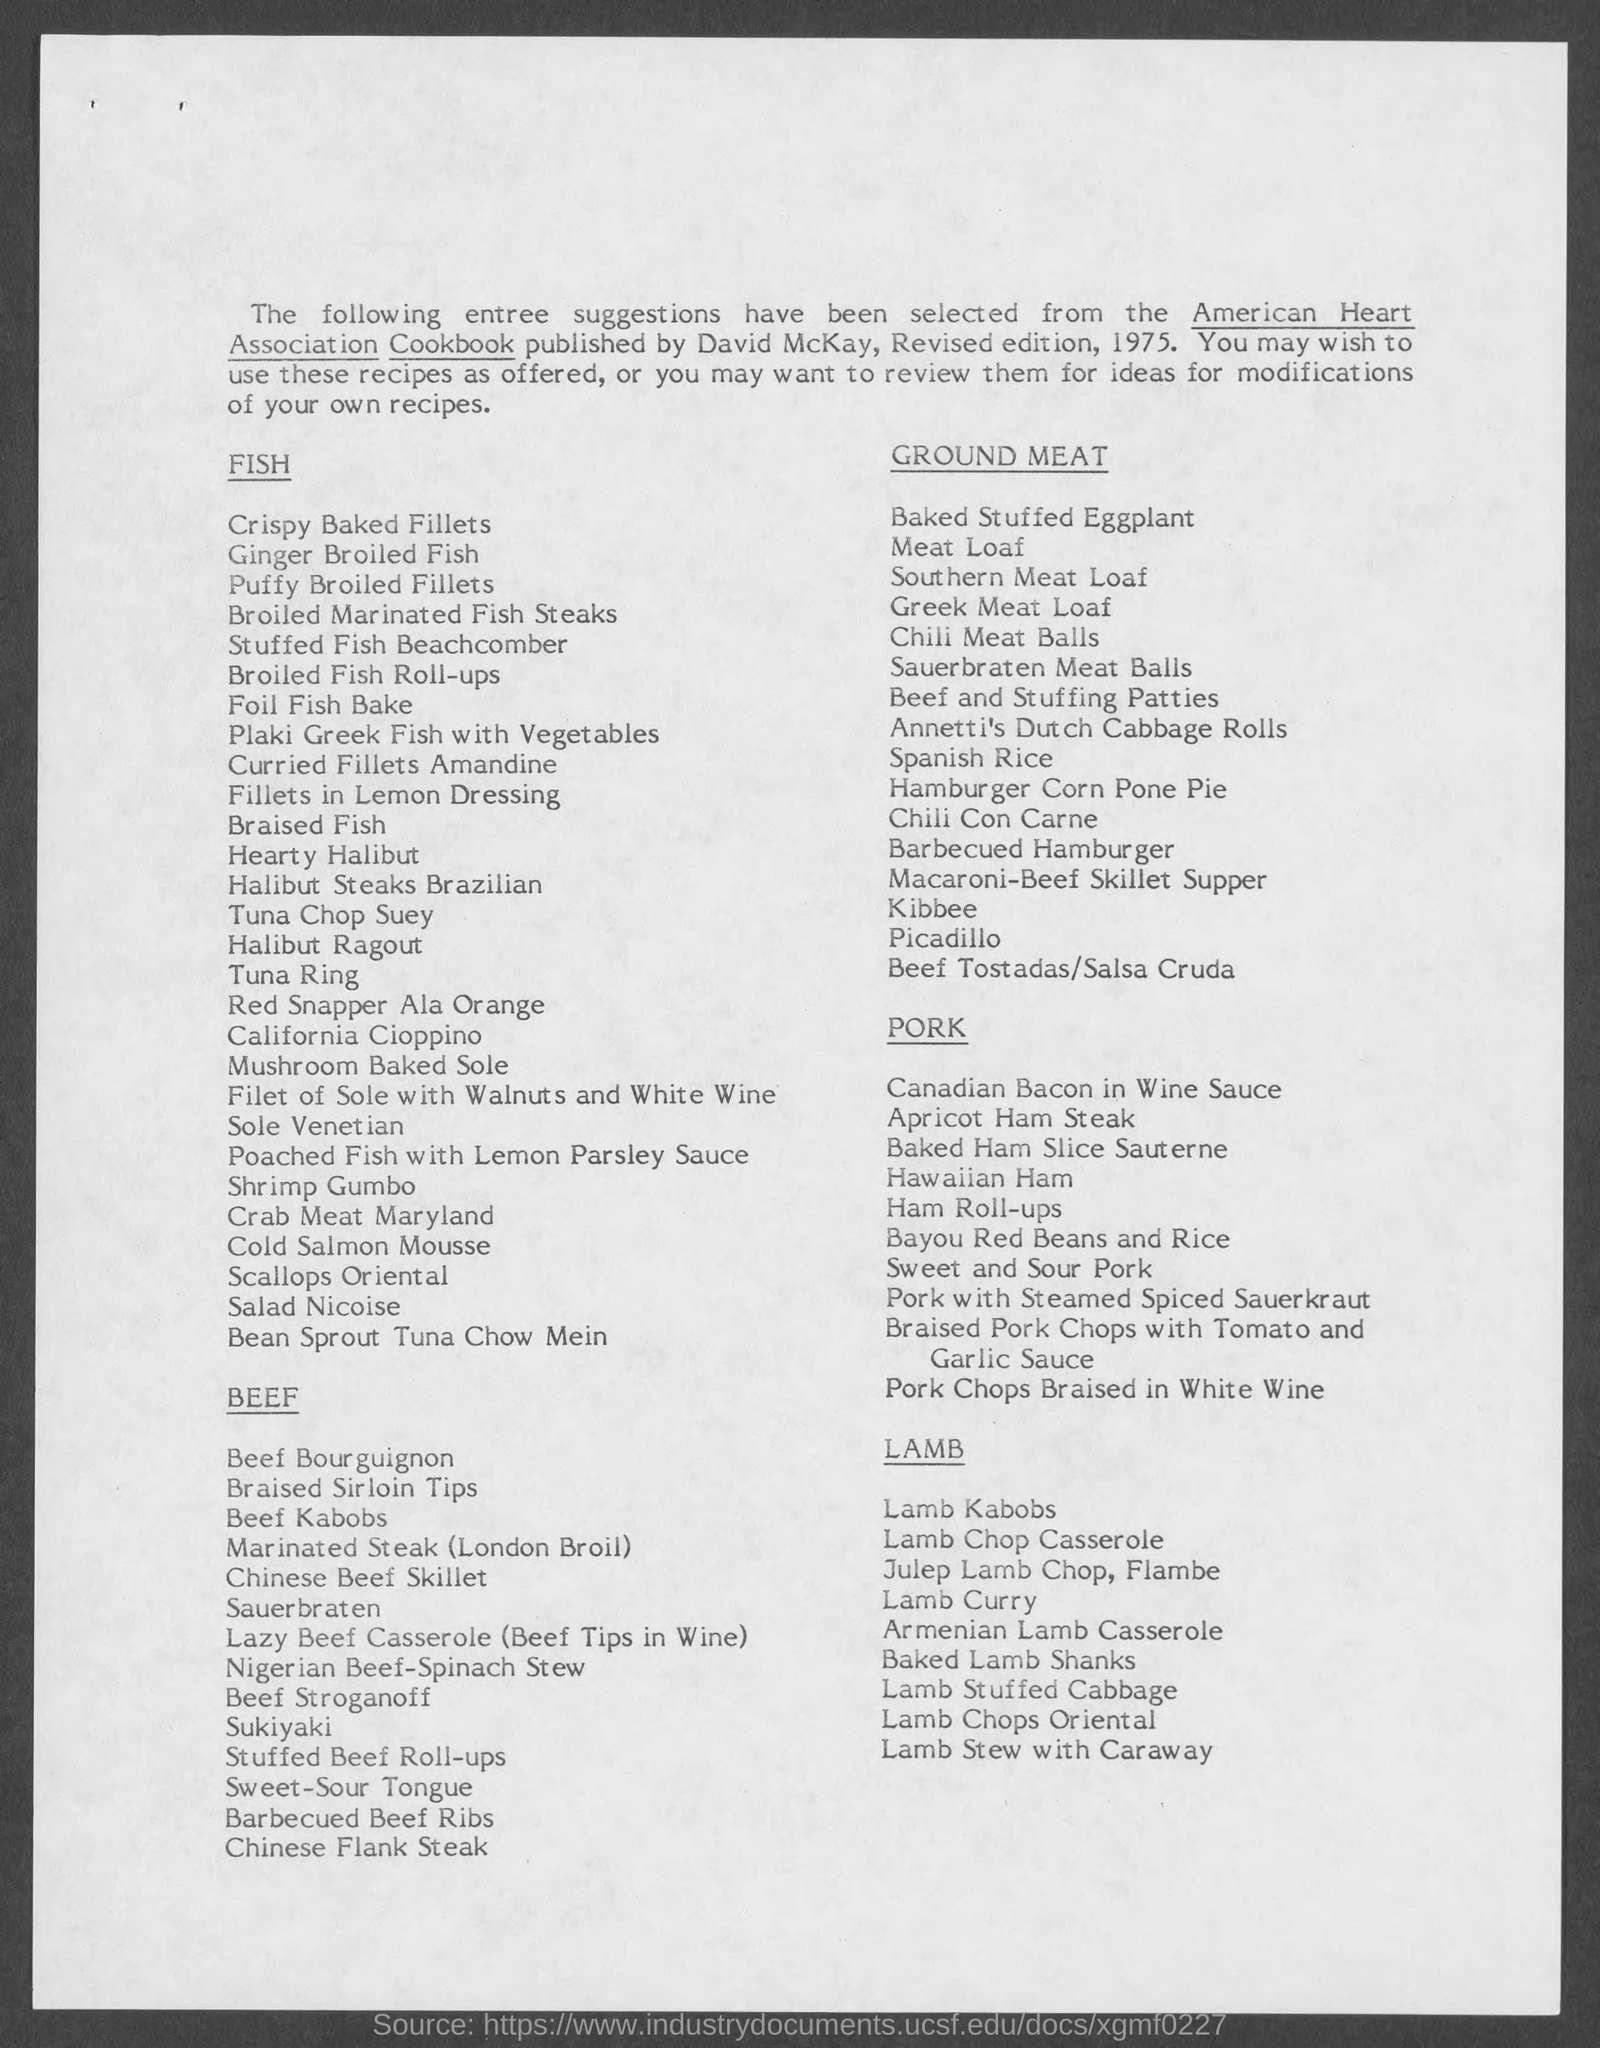Who published american heart association cookbook ?
Make the answer very short. By david mckay. 